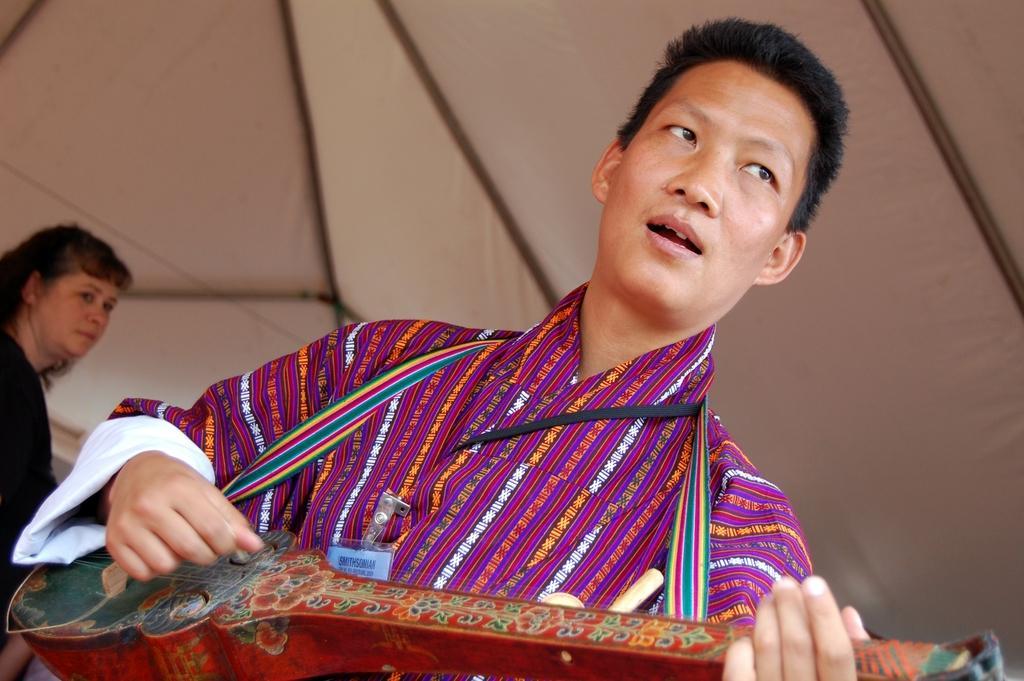How would you summarize this image in a sentence or two? Here in this picture we can see a person playing a musical instrument present in his hand and behind him also we can see another woman standing over there and above them we can see a tent present over there. 